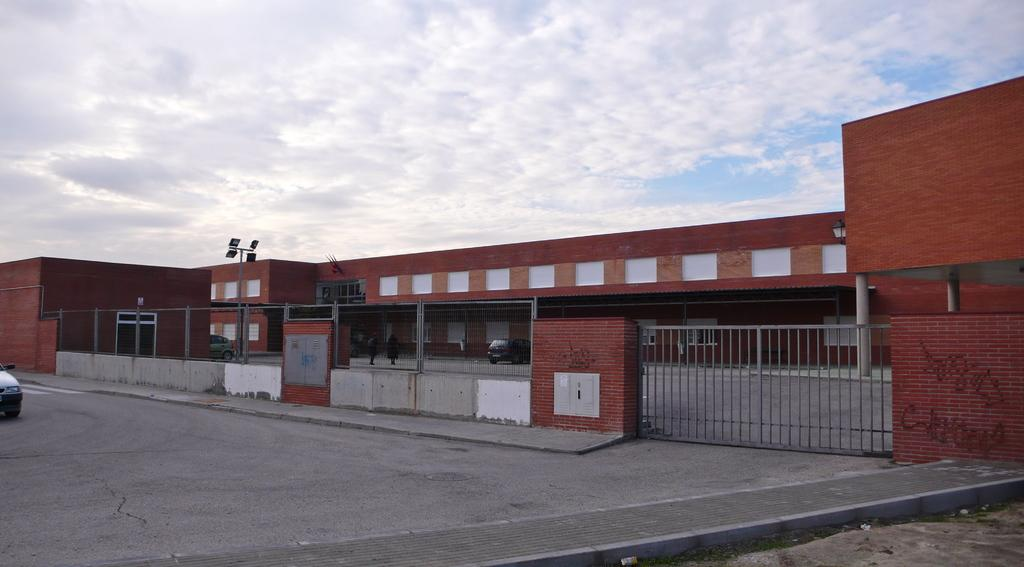What type of structure is visible in the image? There is a building in the image. What is the entrance to the building like? There is a gate in the image. What is located at the bottom of the image? There is a road at the bottom of the image. What can be seen on the left side of the image? There is a car on the left side of the image. What is visible at the top of the image? The sky is visible at the top of the image. What can be observed in the sky? There are clouds in the sky. How many beds can be seen in the image? There are no beds present in the image. What type of jam is being served at the station in the image? There is no station or jam present in the image. 